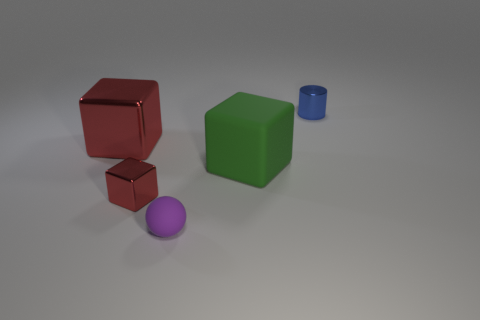Subtract all brown spheres. Subtract all gray blocks. How many spheres are left? 1 Add 4 brown shiny spheres. How many objects exist? 9 Subtract all blocks. How many objects are left? 2 Add 3 large metallic cubes. How many large metallic cubes exist? 4 Subtract 0 purple cubes. How many objects are left? 5 Subtract all tiny purple balls. Subtract all blue objects. How many objects are left? 3 Add 4 tiny red things. How many tiny red things are left? 5 